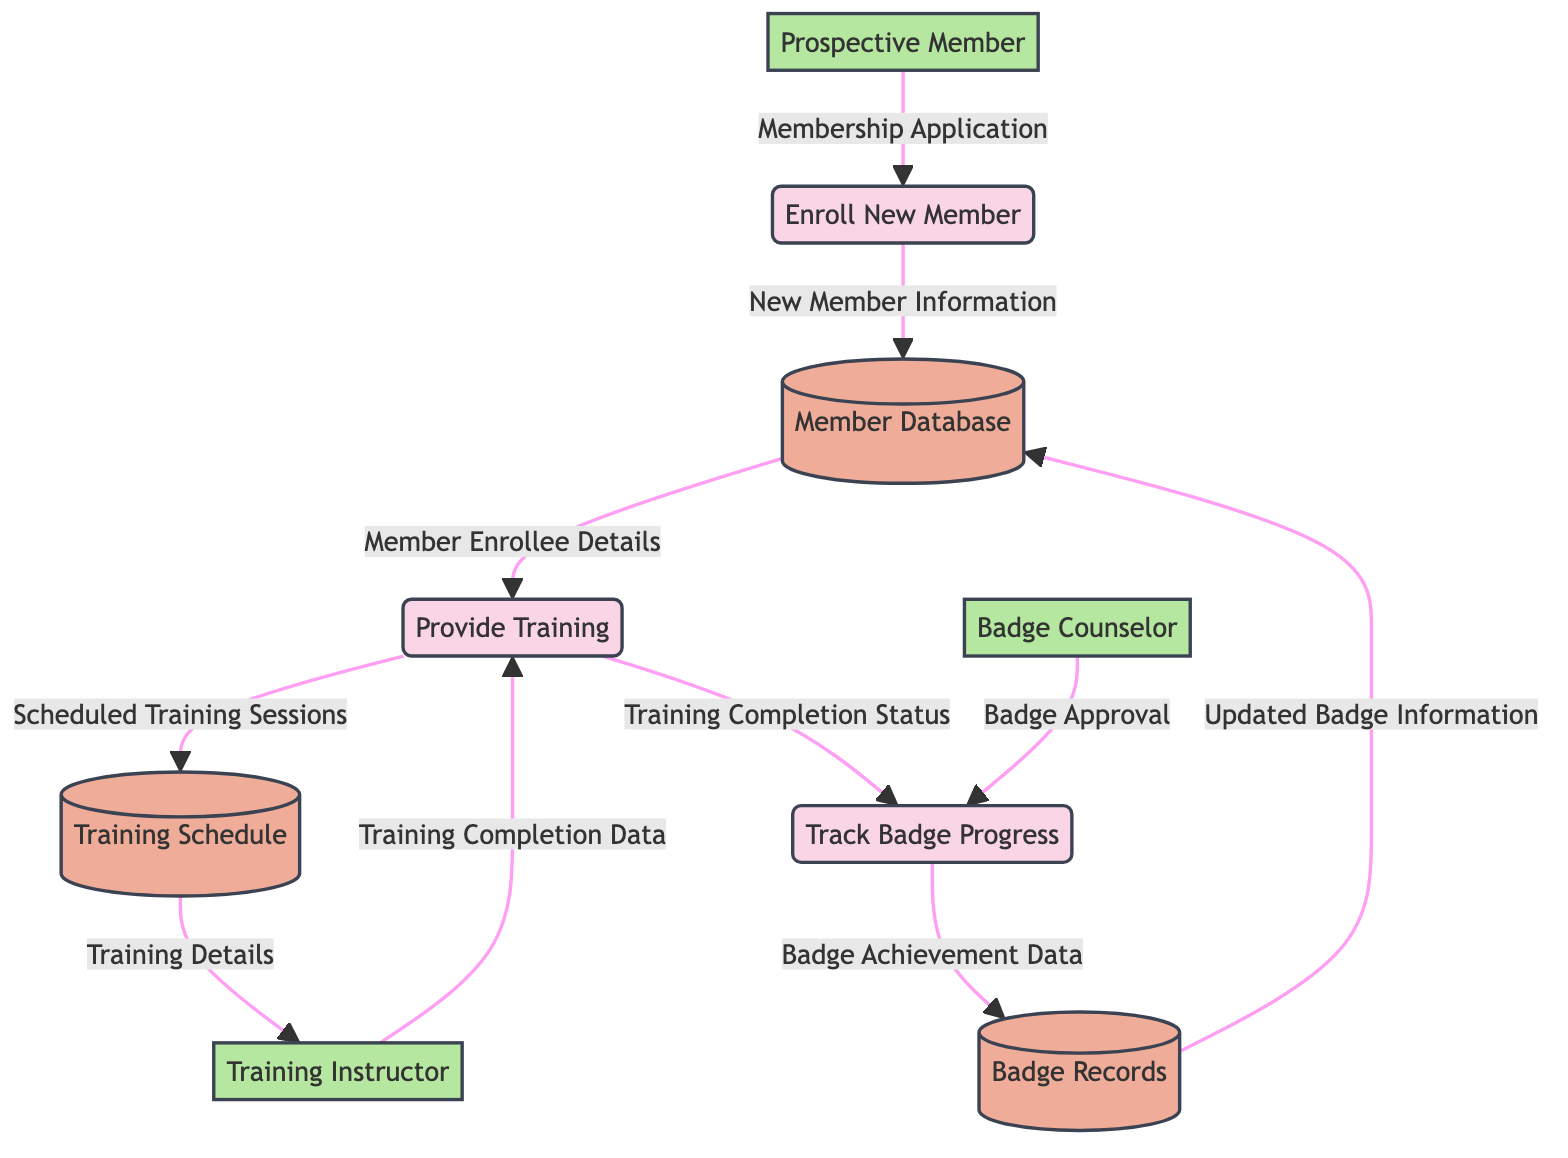What are the three processes in the diagram? The processes listed in the diagram are "Enroll New Member", "Provide Training", and "Track Badge Progress". These can be directly identified from the 'processes' section of the provided data.
Answer: Enroll New Member, Provide Training, Track Badge Progress How many data stores are present in the diagram? The diagram indicates there are three data stores: "Member Database", "Training Schedule", and "Badge Records". Counting these gives the total number of data stores.
Answer: 3 Who is the external entity that seeks membership? The external entity looking for membership is the "Prospective Member". This can be found in the 'externalEntities' section of the data.
Answer: Prospective Member What type of information is sent from "Prospective Member" to "Enroll New Member"? The information transferred is the "Membership Application". This flow is specified in the 'dataFlows' section detailing the communication between these nodes.
Answer: Membership Application What does the "Provide Training" process receive from "Member Database"? It receives "Member Enrollee Details". This can be traced from the data flow that connects "Member Database" to "Provide Training".
Answer: Member Enrollee Details What information does the "Training Instructor" provide back to the "Provide Training" process? The "Training Instructor" sends "Training Completion Data" back to "Provide Training". This flow is noted in the relationships outlined in the diagram.
Answer: Training Completion Data Which external entity approves badges in the "Track Badge Progress" process? The "Badge Counselor" is the external entity that approves badges in the "Track Badge Progress" process as shown in the data flow from the Badge Counselor to Track Badge Progress.
Answer: Badge Counselor What does "Track Badge Progress" send to "Badge Records"? "Track Badge Progress" sends "Badge Achievement Data" to "Badge Records", which is conveyed in the datal flow line connecting these components.
Answer: Badge Achievement Data Which data store is updated with new badge information? The "Member Database" is updated with "Updated Badge Information", as shown by the direction of the data flow from "Badge Records" to "Member Database".
Answer: Member Database 